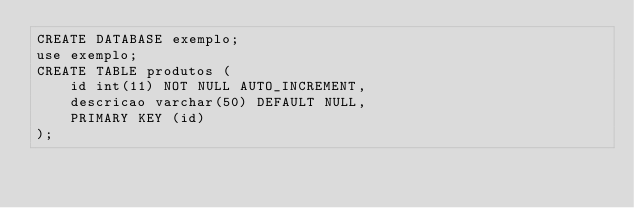Convert code to text. <code><loc_0><loc_0><loc_500><loc_500><_SQL_>CREATE DATABASE exemplo;
use exemplo;
CREATE TABLE produtos (
    id int(11) NOT NULL AUTO_INCREMENT,
    descricao varchar(50) DEFAULT NULL,
    PRIMARY KEY (id)
);</code> 